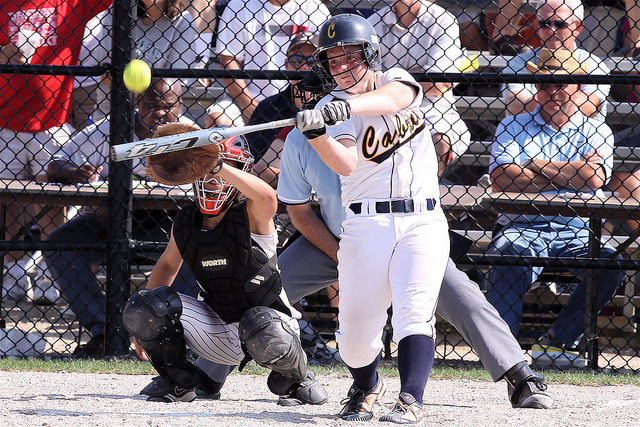From the image, can you deduce if it's a professional game or a casual one? Although the players are wearing uniforms and there are spectators present, pointing to a level of formality, it's challenging to definitively say if it's a professional game or a casual one. The uniforms and spectators hint at a competitive or semi-professional nature, but it could also be a local or school-level game. 